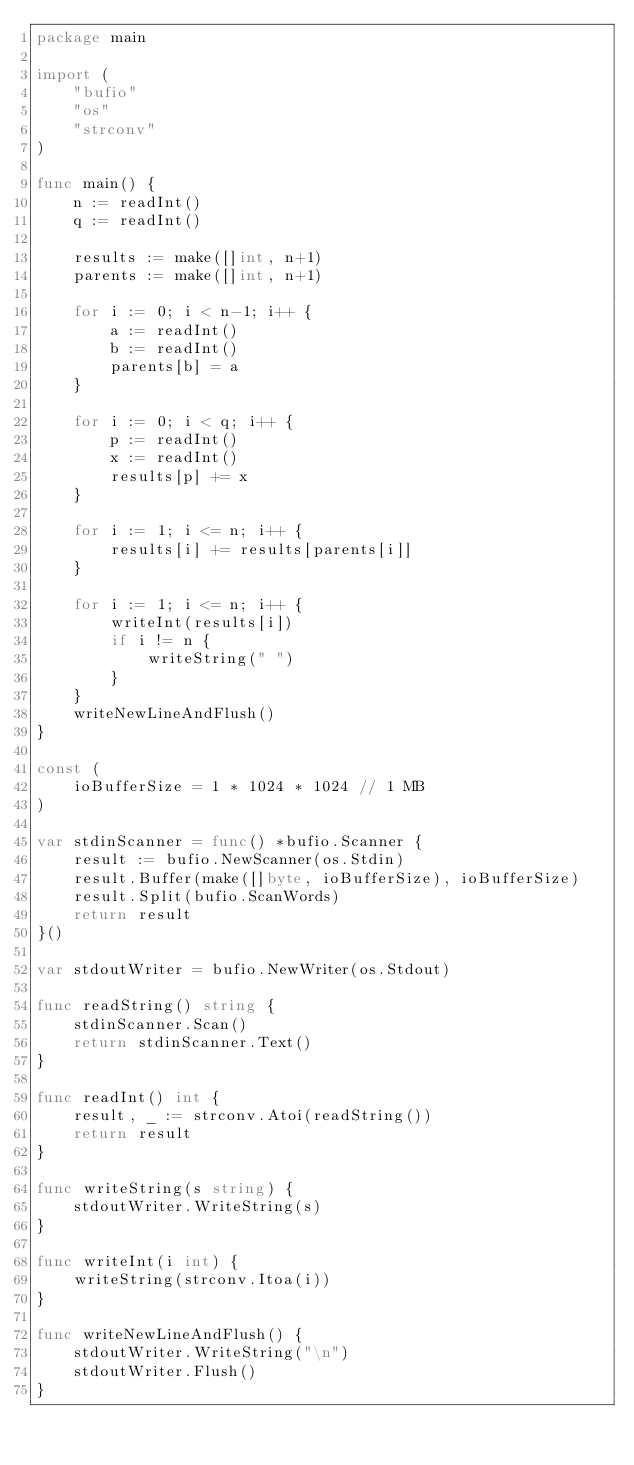Convert code to text. <code><loc_0><loc_0><loc_500><loc_500><_Go_>package main

import (
	"bufio"
	"os"
	"strconv"
)

func main() {
	n := readInt()
	q := readInt()

	results := make([]int, n+1)
	parents := make([]int, n+1)

	for i := 0; i < n-1; i++ {
		a := readInt()
		b := readInt()
		parents[b] = a
	}

	for i := 0; i < q; i++ {
		p := readInt()
		x := readInt()
		results[p] += x
	}

	for i := 1; i <= n; i++ {
		results[i] += results[parents[i]]
	}

	for i := 1; i <= n; i++ {
		writeInt(results[i])
		if i != n {
			writeString(" ")
		}
	}
	writeNewLineAndFlush()
}

const (
	ioBufferSize = 1 * 1024 * 1024 // 1 MB
)

var stdinScanner = func() *bufio.Scanner {
	result := bufio.NewScanner(os.Stdin)
	result.Buffer(make([]byte, ioBufferSize), ioBufferSize)
	result.Split(bufio.ScanWords)
	return result
}()

var stdoutWriter = bufio.NewWriter(os.Stdout)

func readString() string {
	stdinScanner.Scan()
	return stdinScanner.Text()
}

func readInt() int {
	result, _ := strconv.Atoi(readString())
	return result
}

func writeString(s string) {
	stdoutWriter.WriteString(s)
}

func writeInt(i int) {
	writeString(strconv.Itoa(i))
}

func writeNewLineAndFlush() {
	stdoutWriter.WriteString("\n")
	stdoutWriter.Flush()
}
</code> 